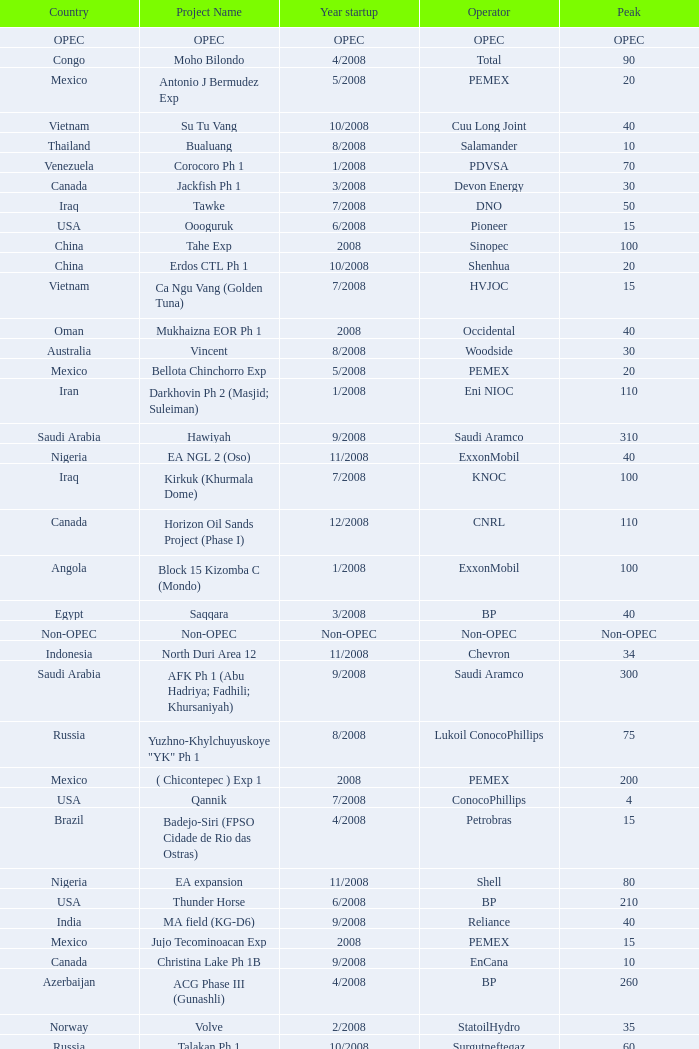Parse the table in full. {'header': ['Country', 'Project Name', 'Year startup', 'Operator', 'Peak'], 'rows': [['OPEC', 'OPEC', 'OPEC', 'OPEC', 'OPEC'], ['Congo', 'Moho Bilondo', '4/2008', 'Total', '90'], ['Mexico', 'Antonio J Bermudez Exp', '5/2008', 'PEMEX', '20'], ['Vietnam', 'Su Tu Vang', '10/2008', 'Cuu Long Joint', '40'], ['Thailand', 'Bualuang', '8/2008', 'Salamander', '10'], ['Venezuela', 'Corocoro Ph 1', '1/2008', 'PDVSA', '70'], ['Canada', 'Jackfish Ph 1', '3/2008', 'Devon Energy', '30'], ['Iraq', 'Tawke', '7/2008', 'DNO', '50'], ['USA', 'Oooguruk', '6/2008', 'Pioneer', '15'], ['China', 'Tahe Exp', '2008', 'Sinopec', '100'], ['China', 'Erdos CTL Ph 1', '10/2008', 'Shenhua', '20'], ['Vietnam', 'Ca Ngu Vang (Golden Tuna)', '7/2008', 'HVJOC', '15'], ['Oman', 'Mukhaizna EOR Ph 1', '2008', 'Occidental', '40'], ['Australia', 'Vincent', '8/2008', 'Woodside', '30'], ['Mexico', 'Bellota Chinchorro Exp', '5/2008', 'PEMEX', '20'], ['Iran', 'Darkhovin Ph 2 (Masjid; Suleiman)', '1/2008', 'Eni NIOC', '110'], ['Saudi Arabia', 'Hawiyah', '9/2008', 'Saudi Aramco', '310'], ['Nigeria', 'EA NGL 2 (Oso)', '11/2008', 'ExxonMobil', '40'], ['Iraq', 'Kirkuk (Khurmala Dome)', '7/2008', 'KNOC', '100'], ['Canada', 'Horizon Oil Sands Project (Phase I)', '12/2008', 'CNRL', '110'], ['Angola', 'Block 15 Kizomba C (Mondo)', '1/2008', 'ExxonMobil', '100'], ['Egypt', 'Saqqara', '3/2008', 'BP', '40'], ['Non-OPEC', 'Non-OPEC', 'Non-OPEC', 'Non-OPEC', 'Non-OPEC'], ['Indonesia', 'North Duri Area 12', '11/2008', 'Chevron', '34'], ['Saudi Arabia', 'AFK Ph 1 (Abu Hadriya; Fadhili; Khursaniyah)', '9/2008', 'Saudi Aramco', '300'], ['Russia', 'Yuzhno-Khylchuyuskoye "YK" Ph 1', '8/2008', 'Lukoil ConocoPhillips', '75'], ['Mexico', '( Chicontepec ) Exp 1', '2008', 'PEMEX', '200'], ['USA', 'Qannik', '7/2008', 'ConocoPhillips', '4'], ['Brazil', 'Badejo-Siri (FPSO Cidade de Rio das Ostras)', '4/2008', 'Petrobras', '15'], ['Nigeria', 'EA expansion', '11/2008', 'Shell', '80'], ['USA', 'Thunder Horse', '6/2008', 'BP', '210'], ['India', 'MA field (KG-D6)', '9/2008', 'Reliance', '40'], ['Mexico', 'Jujo Tecominoacan Exp', '2008', 'PEMEX', '15'], ['Canada', 'Christina Lake Ph 1B', '9/2008', 'EnCana', '10'], ['Azerbaijan', 'ACG Phase III (Gunashli)', '4/2008', 'BP', '260'], ['Norway', 'Volve', '2/2008', 'StatoilHydro', '35'], ['Russia', 'Talakan Ph 1', '10/2008', 'Surgutneftegaz', '60'], ['Canada', 'Christina Lake Ph 2', '8/2008', 'MEG Energy (CNOOC interest)', '20'], ['Kazakhstan', 'Komsomolskoe', '5/2008', 'Petrom', '10'], ['Kuwait', 'Project Kuwait Phase I', '12/2008', 'KOC', '50'], ['USA', 'Blind Faith', '11/2008', 'Chevron', '45'], ['Vietnam', 'Song Doc', '12/2008', 'Talisman', '10'], ['Angola', 'Block 15 Kizomba C (Saxi; Batuque)', '7/2008', 'ExxonMobil', '100'], ['Canada', 'Long Lake Upgrader Ph 1', '8/2008', 'OPTI /Nexen', '60'], ['Canada', 'Millennium Coker Unit', '2008', 'Suncor', '30'], ['Iran', 'Aghajari Exp', '4/2008', 'NIOC', '120'], ['Brazil', 'Marlim Leste P-53', '11/2008', 'Petrobras', '180'], ['Nigeria', 'Agbami', '7/2008', 'Chevron', '230'], ['China', 'Xijiang 23-1', '6/2008', 'CNOOC', '40'], ['Russia', 'Verkhnechonsk Ph 1 (early oil)', '10/2008', 'TNK-BP Rosneft', '20'], ['Iran', 'South Pars phase 6-7-8', '10/2008', 'Statoil', '180'], ['China', 'Wenchang Exp', '7/2008', 'CNOOC', '40'], ['USA', 'Neptune', '7/2008', 'BHP Billiton', '25'], ['Kazakhstan', 'Dunga', '3/2008', 'Maersk', '150'], ['Mexico', 'Ixtal Manik', '2008', 'PEMEX', '55'], ['Australia', 'Angel', '10/2008', 'NWS Venture', '50'], ['Norway', 'Alvheim; Volund; Vilje', '6/2008', 'Marathon', '100'], ['Philippines', 'Galoc', '10/2008', 'GPC', '15'], ['Iran', 'Azadegan Phase I (south)', '2/2008', 'NIOC', '160'], ['USA', 'Ursa Princess Exp', '1/2008', 'Shell', '30'], ['Brazil', 'Cachalote Pilot (Baleia Franca)', '12/2008', 'Petrobras', '25'], ['UK', 'Britannia Satellites (Callanish; Brodgar)', '7/2008', 'Conoco Phillips', '25']]} What is the Peak with a Project Name that is talakan ph 1? 60.0. 